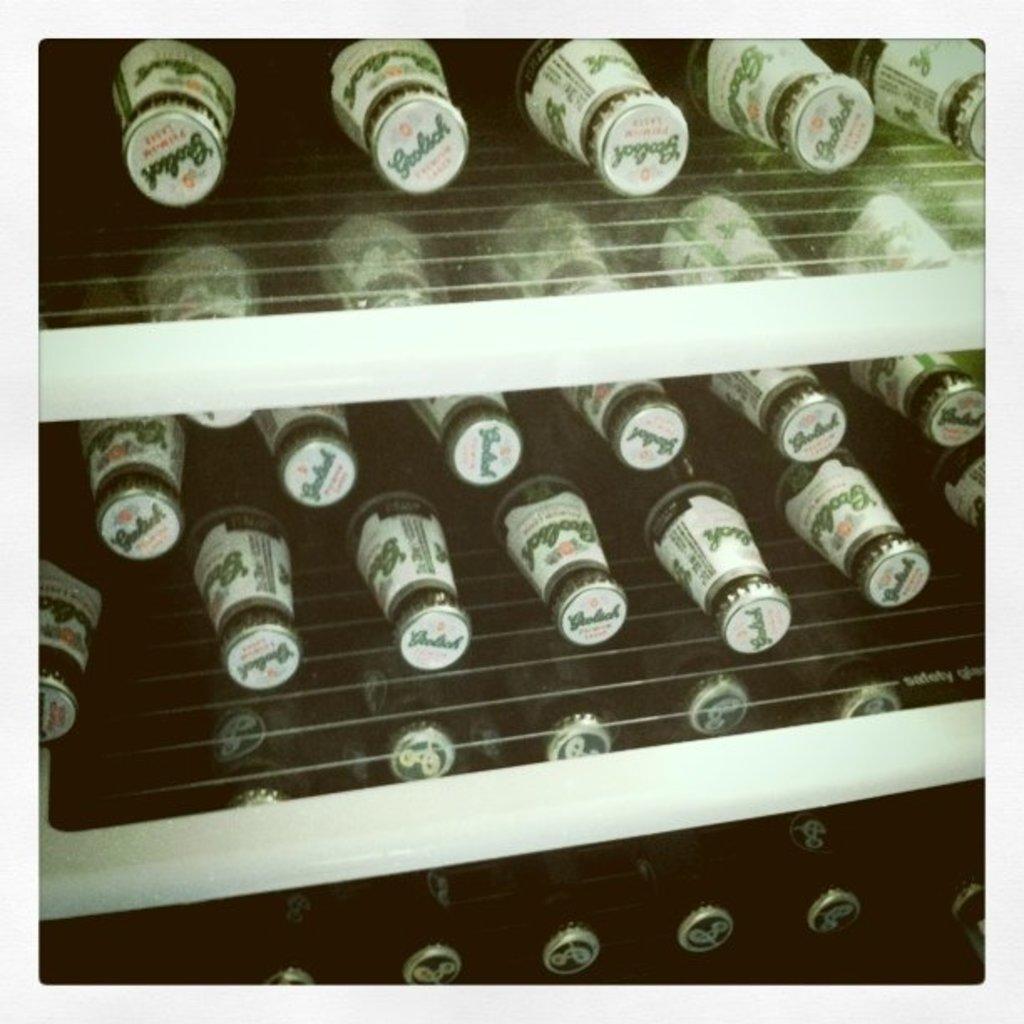Please provide a concise description of this image. In this picture there are the bottles, group of bottles on the shelf. 